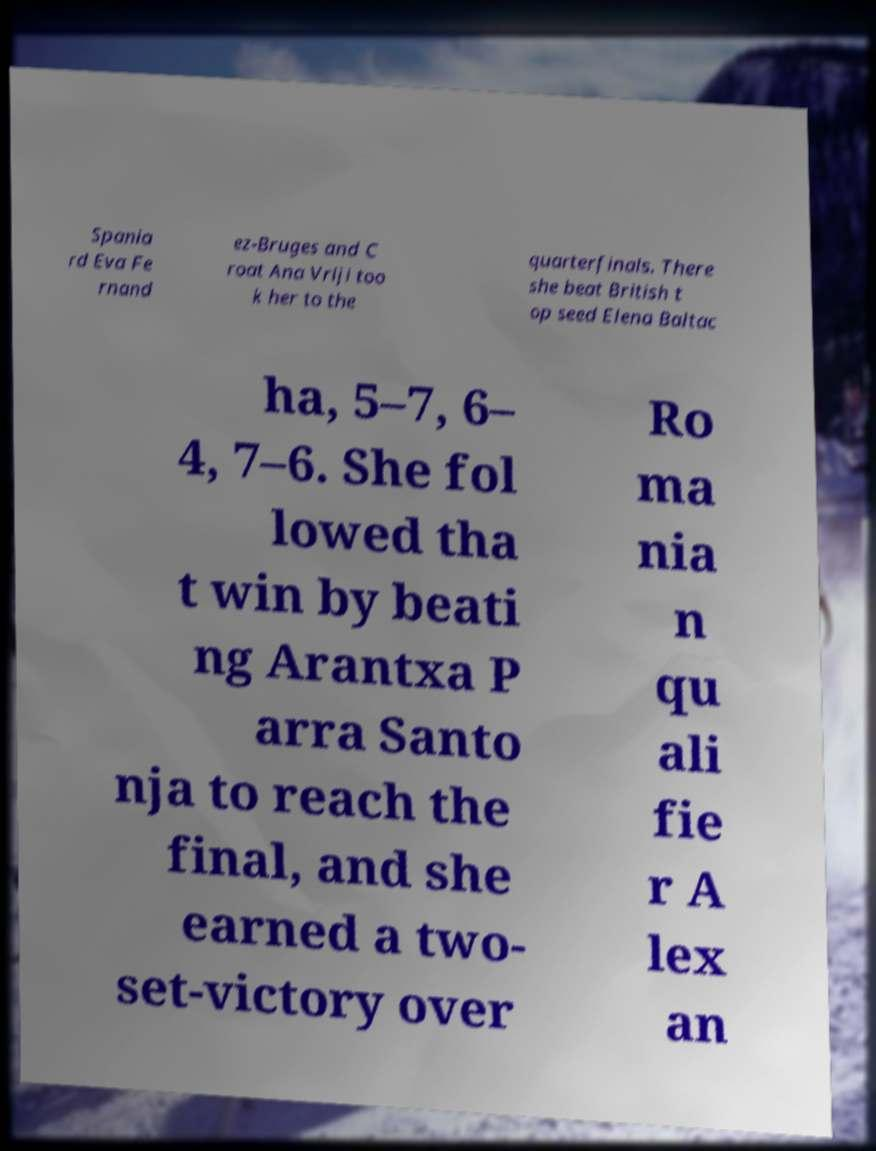Can you read and provide the text displayed in the image?This photo seems to have some interesting text. Can you extract and type it out for me? Spania rd Eva Fe rnand ez-Bruges and C roat Ana Vrlji too k her to the quarterfinals. There she beat British t op seed Elena Baltac ha, 5–7, 6– 4, 7–6. She fol lowed tha t win by beati ng Arantxa P arra Santo nja to reach the final, and she earned a two- set-victory over Ro ma nia n qu ali fie r A lex an 